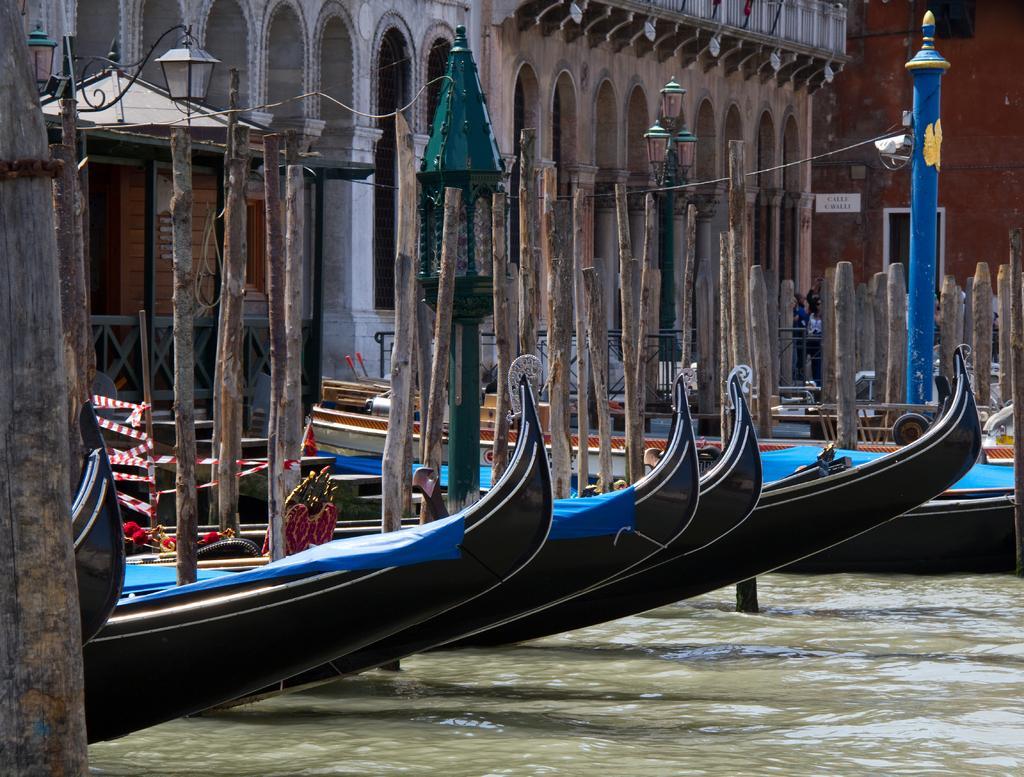Can you describe this image briefly? In this image there is the water. There are boats on the water. Behind the boats there are buildings. To the left there are street light poles and a wooden railing. 